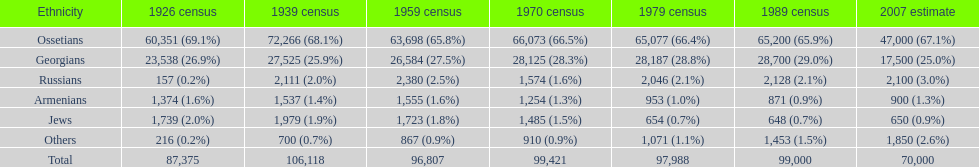Which community possessed the largest population in 1926? Ossetians. 